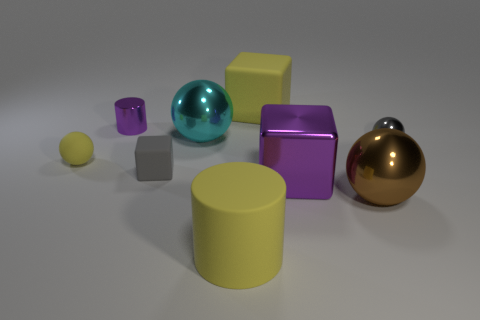Is the size of the purple metal thing that is right of the yellow matte cube the same as the brown thing?
Your response must be concise. Yes. There is a tiny object to the right of the metallic ball that is in front of the rubber ball; what number of balls are to the left of it?
Provide a short and direct response. 3. What size is the object that is to the left of the brown metallic ball and in front of the large purple block?
Offer a terse response. Large. What number of other objects are the same shape as the gray matte object?
Your answer should be compact. 2. What number of yellow matte objects are in front of the large purple thing?
Keep it short and to the point. 1. Are there fewer tiny metal spheres behind the yellow cube than purple cubes behind the small gray block?
Your answer should be compact. No. The purple metal thing in front of the large metallic sphere to the left of the big object behind the small cylinder is what shape?
Provide a succinct answer. Cube. There is a shiny object that is both to the left of the yellow cube and on the right side of the tiny gray cube; what shape is it?
Your response must be concise. Sphere. Is there a brown thing that has the same material as the cyan thing?
Keep it short and to the point. Yes. There is a block that is the same color as the big cylinder; what is its size?
Your response must be concise. Large. 